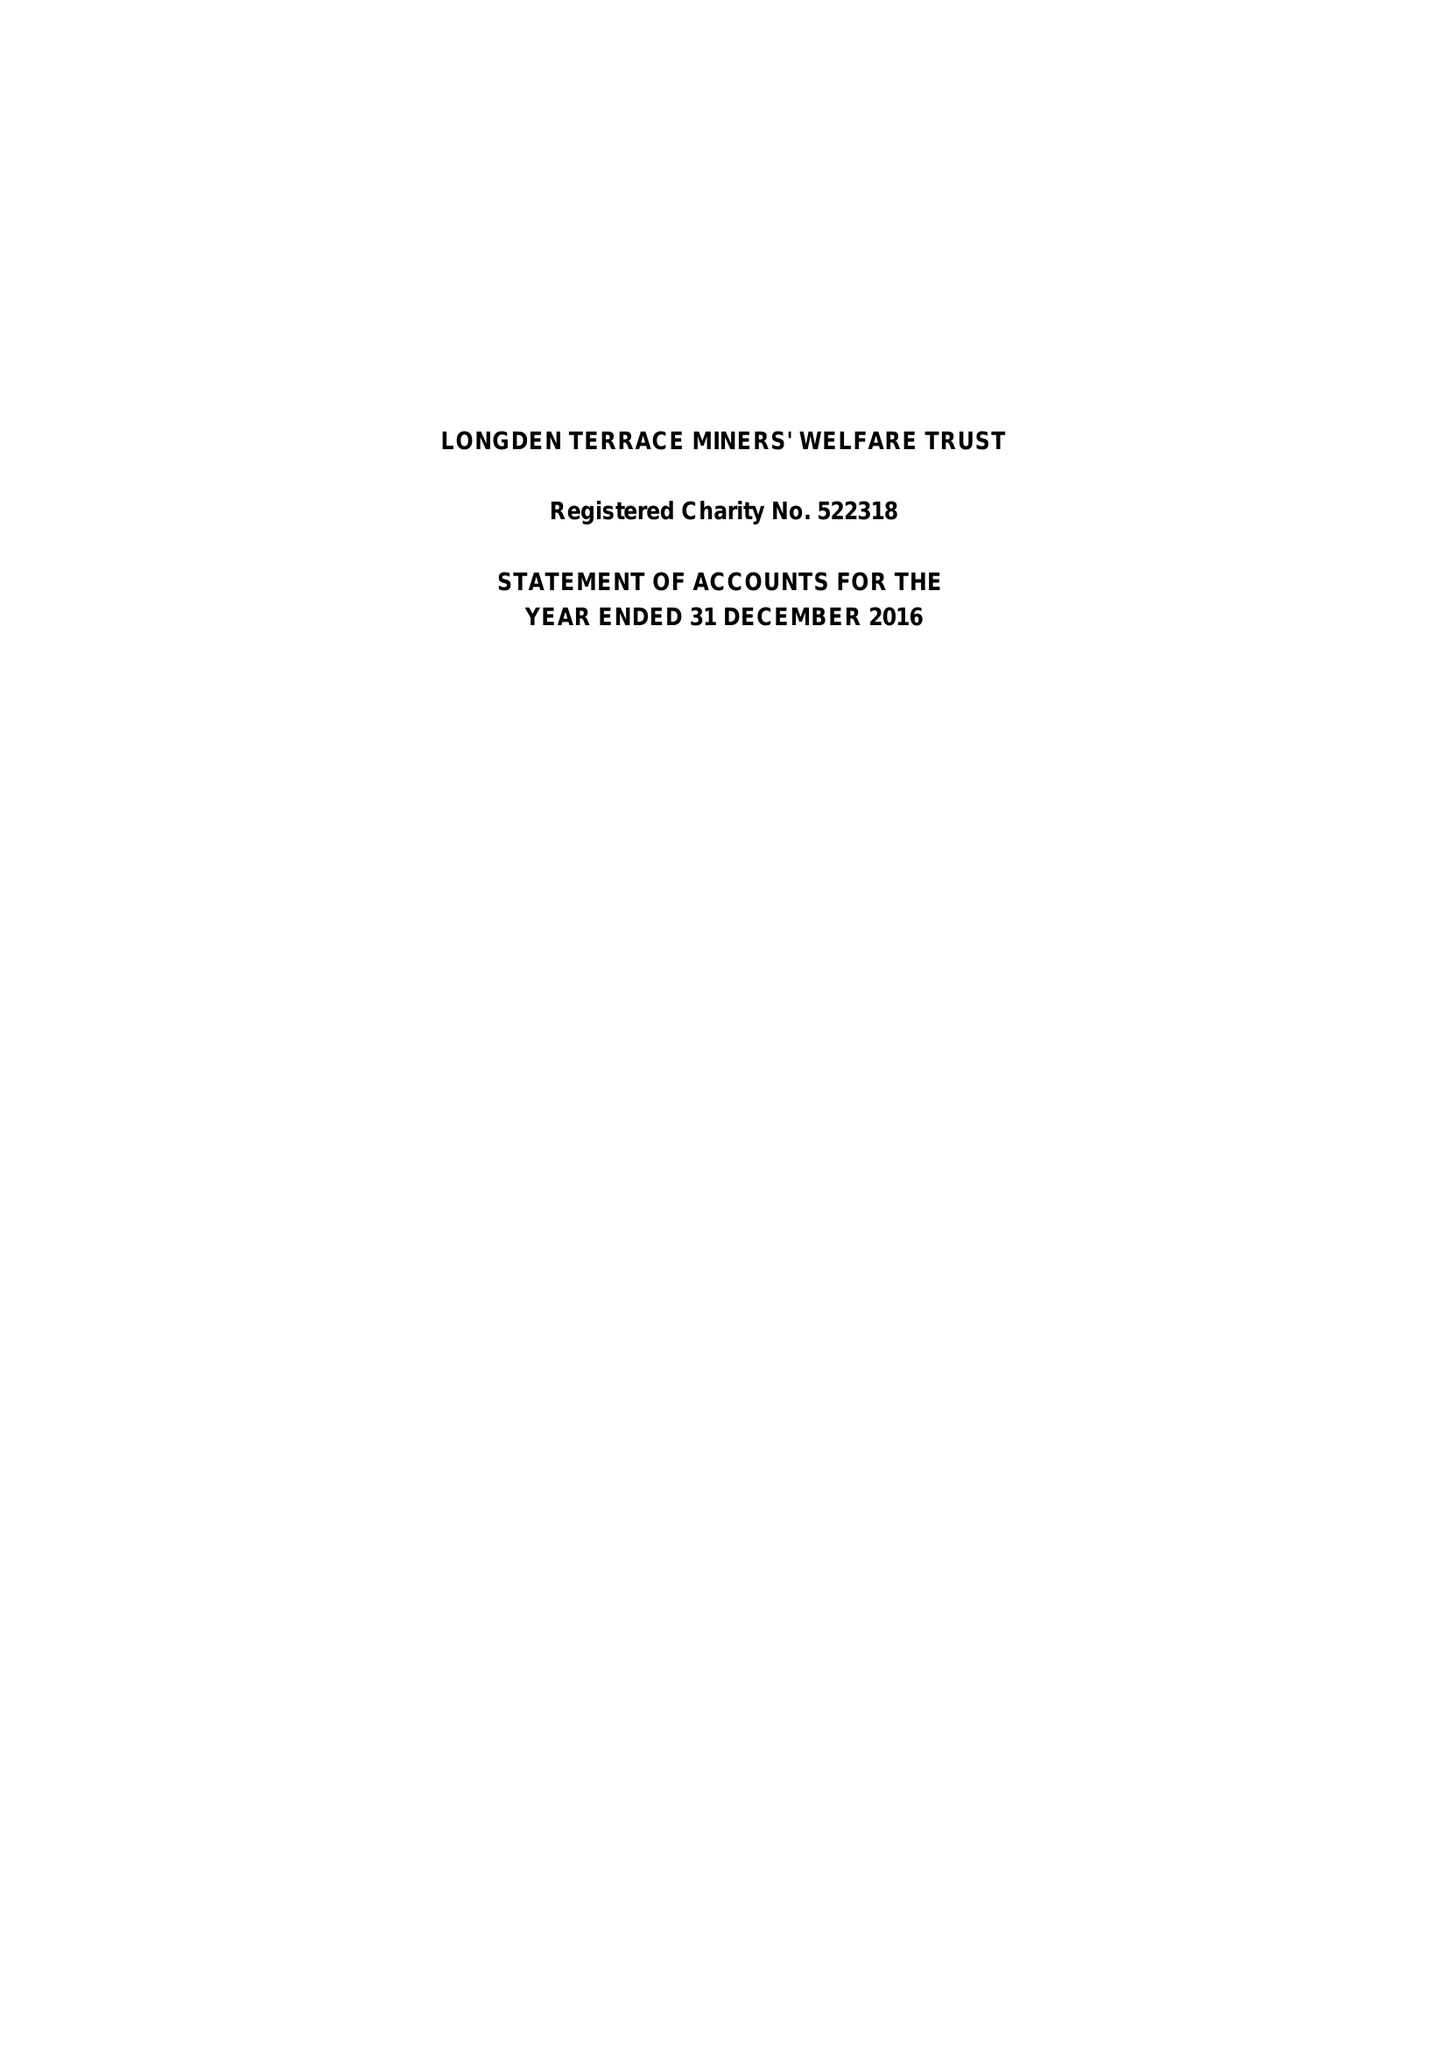What is the value for the address__street_line?
Answer the question using a single word or phrase. 8 BROCKLEHURST DRIVE 